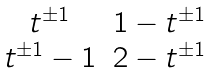Convert formula to latex. <formula><loc_0><loc_0><loc_500><loc_500>\begin{matrix} t ^ { \pm 1 } & 1 - t ^ { \pm 1 } \\ t ^ { \pm 1 } - 1 & 2 - t ^ { \pm 1 } \end{matrix}</formula> 